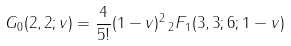Convert formula to latex. <formula><loc_0><loc_0><loc_500><loc_500>G _ { 0 } ( 2 , 2 ; v ) = \frac { 4 } { 5 ! } ( 1 - v ) ^ { 2 } \, _ { 2 } F _ { 1 } ( 3 , 3 ; 6 ; 1 - v )</formula> 